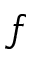<formula> <loc_0><loc_0><loc_500><loc_500>\mathfrak { f }</formula> 